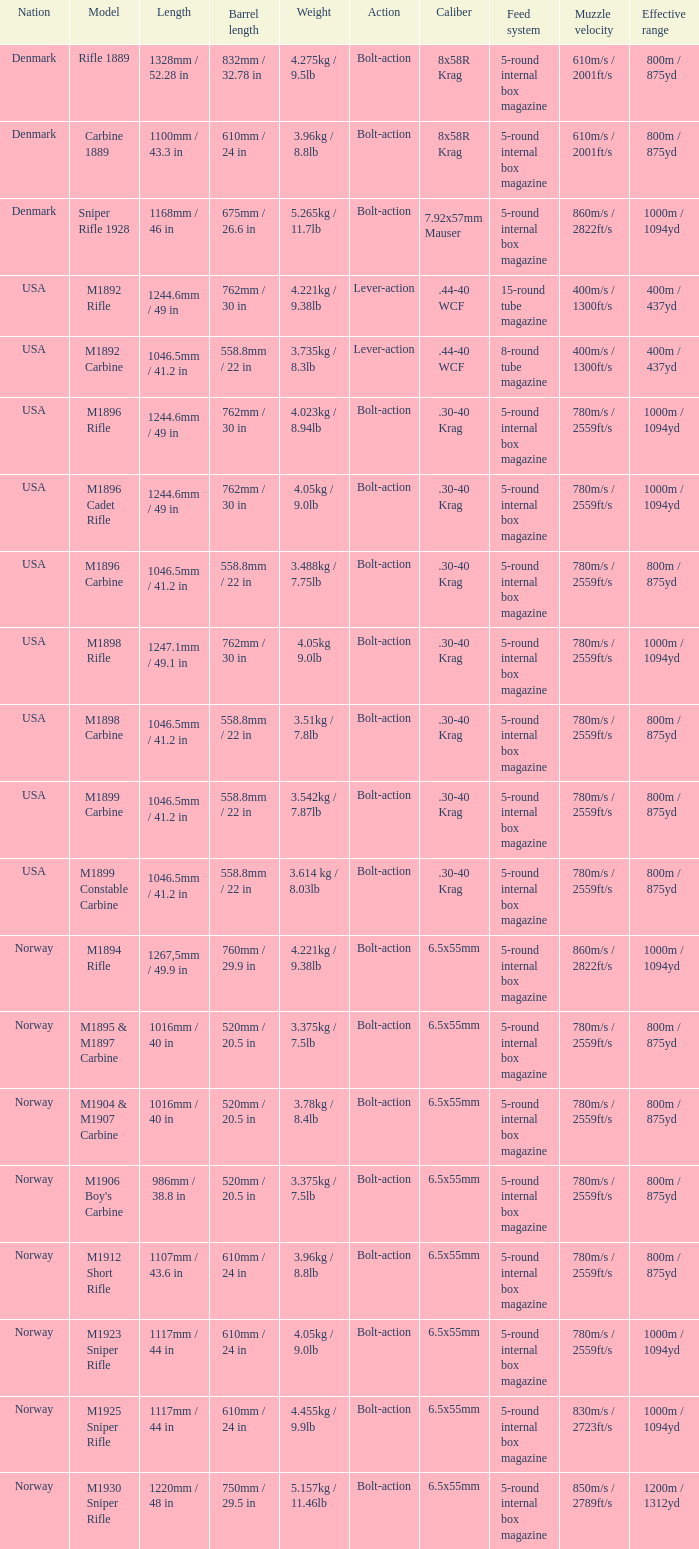What is Nation, when Model is M1895 & M1897 Carbine? Norway. 